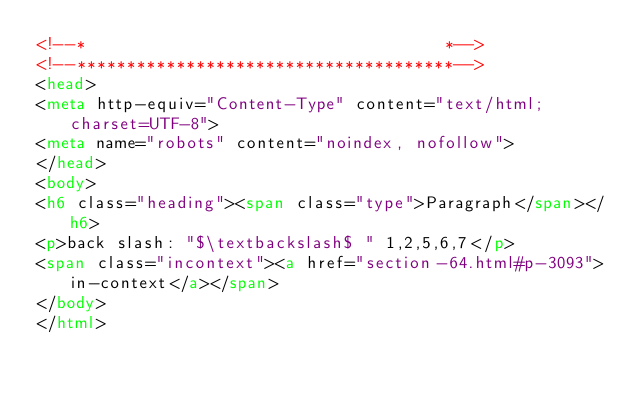Convert code to text. <code><loc_0><loc_0><loc_500><loc_500><_HTML_><!--*                                    *-->
<!--**************************************-->
<head>
<meta http-equiv="Content-Type" content="text/html; charset=UTF-8">
<meta name="robots" content="noindex, nofollow">
</head>
<body>
<h6 class="heading"><span class="type">Paragraph</span></h6>
<p>back slash: "$\textbackslash$ " 1,2,5,6,7</p>
<span class="incontext"><a href="section-64.html#p-3093">in-context</a></span>
</body>
</html>
</code> 